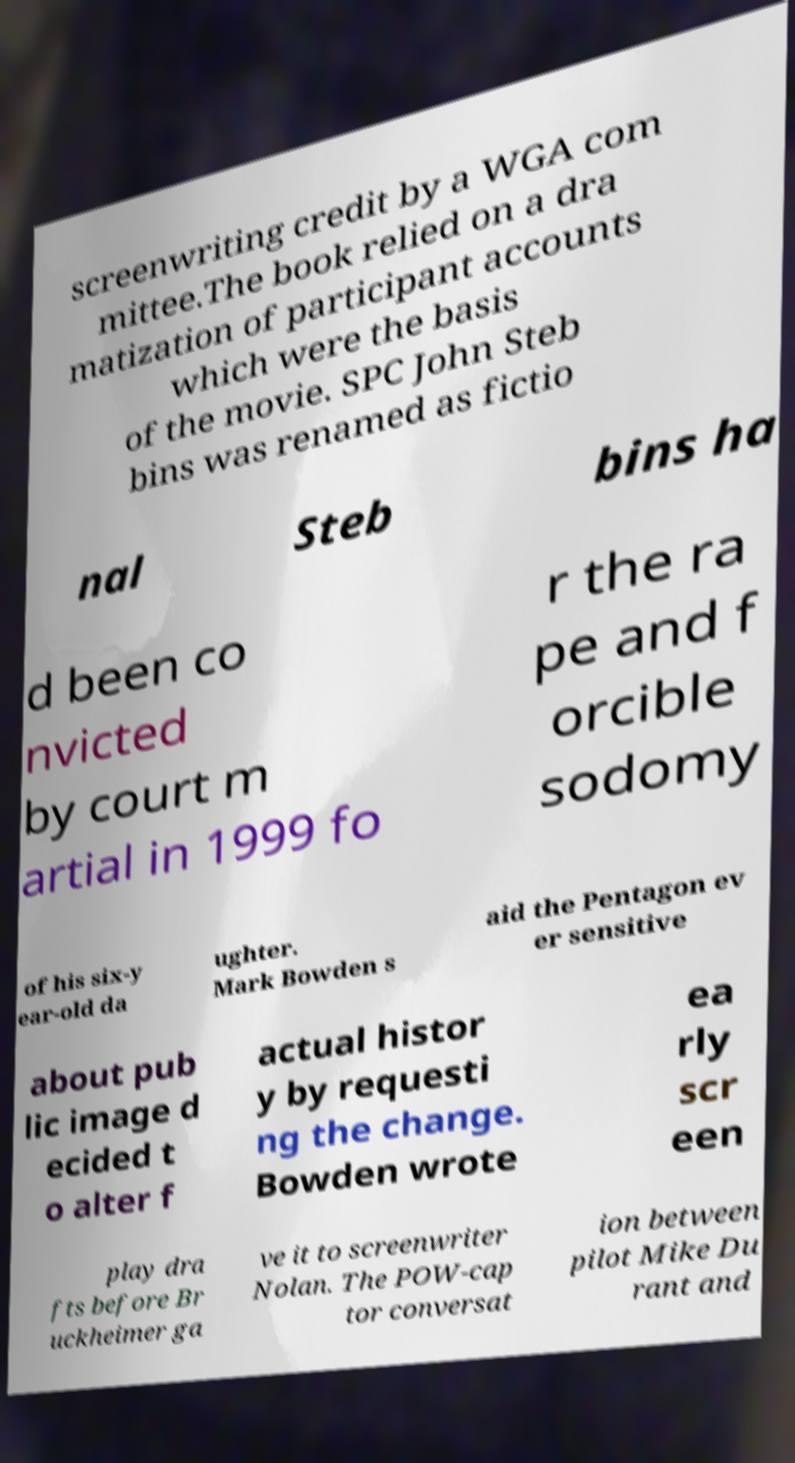For documentation purposes, I need the text within this image transcribed. Could you provide that? screenwriting credit by a WGA com mittee.The book relied on a dra matization of participant accounts which were the basis of the movie. SPC John Steb bins was renamed as fictio nal Steb bins ha d been co nvicted by court m artial in 1999 fo r the ra pe and f orcible sodomy of his six-y ear-old da ughter. Mark Bowden s aid the Pentagon ev er sensitive about pub lic image d ecided t o alter f actual histor y by requesti ng the change. Bowden wrote ea rly scr een play dra fts before Br uckheimer ga ve it to screenwriter Nolan. The POW-cap tor conversat ion between pilot Mike Du rant and 